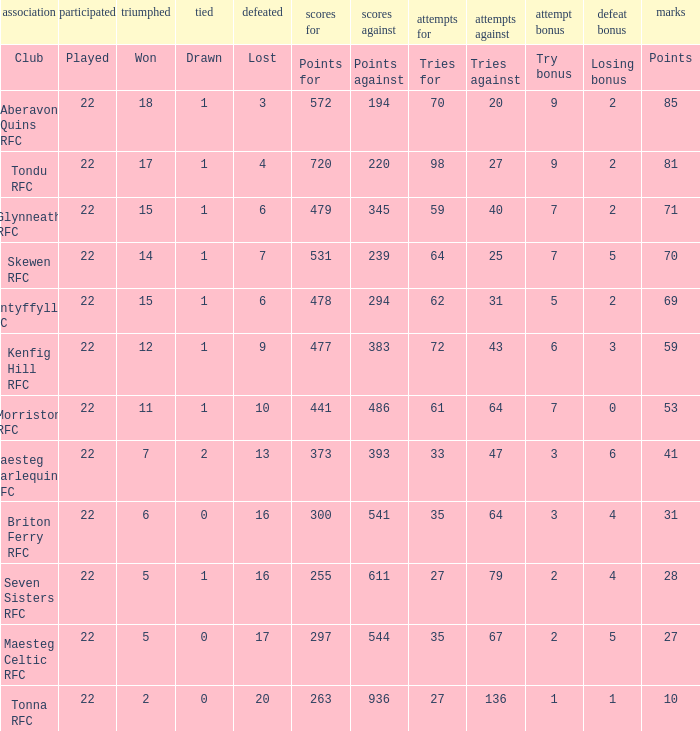How many tries against got the club with 62 tries for? 31.0. 